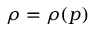<formula> <loc_0><loc_0><loc_500><loc_500>\rho = ( p )</formula> 